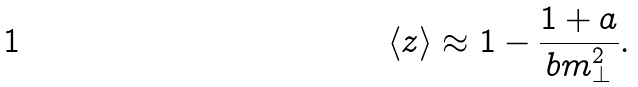<formula> <loc_0><loc_0><loc_500><loc_500>\langle z \rangle \approx 1 - \frac { 1 + a } { b m _ { \perp } ^ { 2 } } .</formula> 